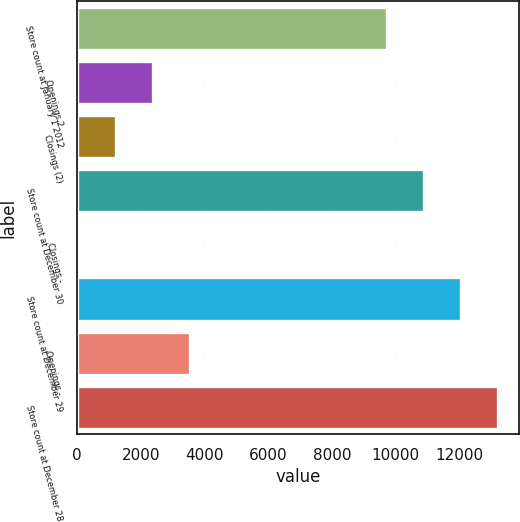<chart> <loc_0><loc_0><loc_500><loc_500><bar_chart><fcel>Store count at January 1 2012<fcel>Openings 2<fcel>Closings (2)<fcel>Store count at December 30<fcel>Closings -<fcel>Store count at December 29<fcel>Openings -<fcel>Store count at December 28<nl><fcel>9742<fcel>2393<fcel>1238.5<fcel>10896.5<fcel>84<fcel>12051<fcel>3547.5<fcel>13205.5<nl></chart> 